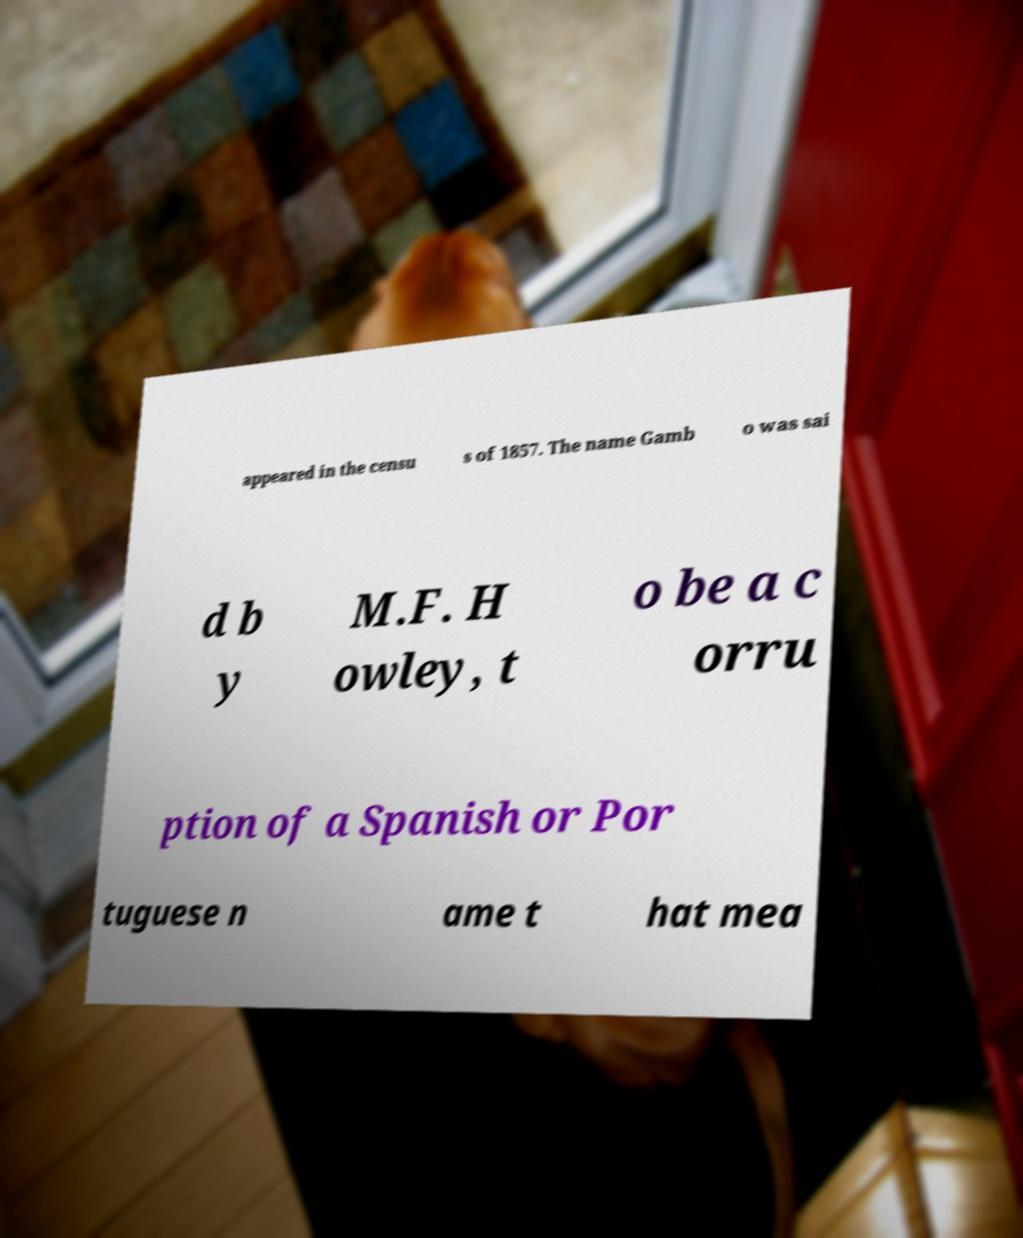Could you extract and type out the text from this image? appeared in the censu s of 1857. The name Gamb o was sai d b y M.F. H owley, t o be a c orru ption of a Spanish or Por tuguese n ame t hat mea 